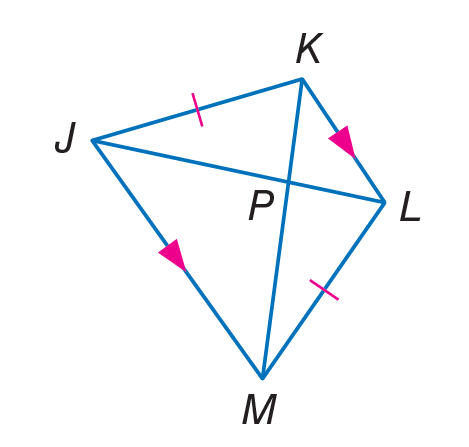Question: Find J L, if K P = 4 and P M = 7.
Choices:
A. 3
B. 4
C. 7
D. 11
Answer with the letter. Answer: D 